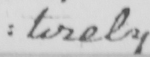Can you read and transcribe this handwriting? : tirely 